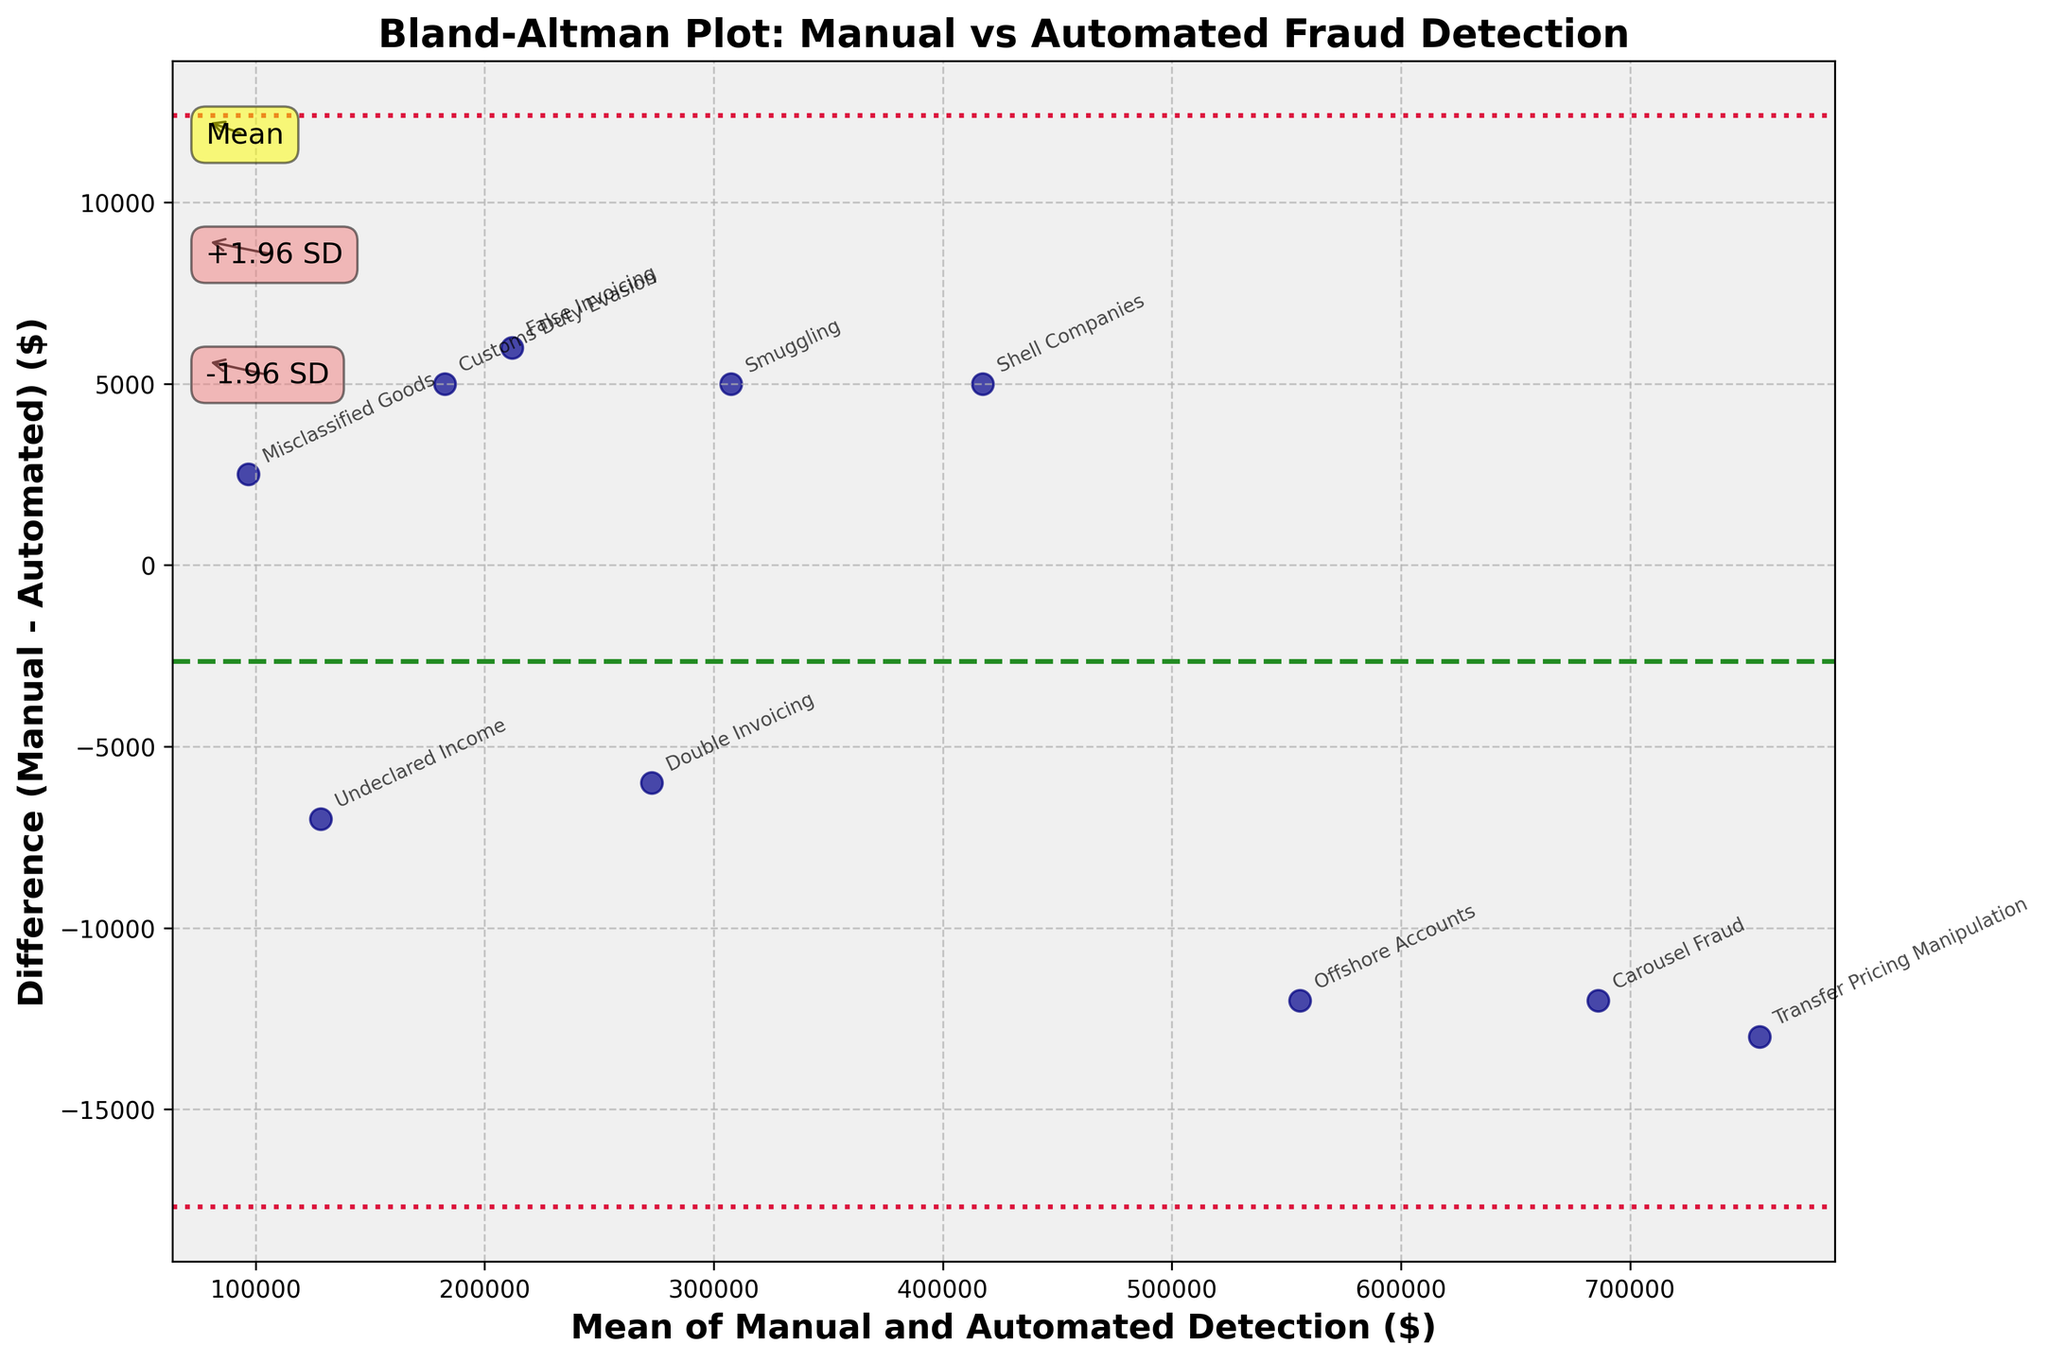What is the title of the plot? The title of the plot is written at the top of the figure in bold font, which provides an overview of what the plot represents.
Answer: Bland-Altman Plot: Manual vs Automated Fraud Detection How many types of fraud detection methods are compared in the plot? Count the number of distinct labels (methods) annotated in the scatter plot. There are 10 different labels in the figure.
Answer: 10 What do the green and red lines represent in the plot? The green dashed line represents the mean difference between the manual and automated detection methods. The red dotted lines represent the limits of agreement (mean ± 1.96 standard deviations).
Answer: Mean difference, Limits of agreement Which fraud detection method shows the largest difference between manual and automated detection? Identify the point with the highest (or lowest) position on the y-axis, which corresponds to the difference (manual - automated). "Transfer Pricing Manipulation" shows the largest positive difference.
Answer: Transfer Pricing Manipulation What is the mean difference between the manual and automated detection methods? The mean difference is marked by the green dashed line and labeled "Mean" on the y-axis.
Answer: Approximately 4,700 Are there any points that fall outside the limits of agreement? Check if any points fall above the upper red dotted line (+1.96 SD) or below the lower red dotted line (-1.96 SD).
Answer: No What is the mean detection value for Misclassified Goods across both methods? Find the mean of the manual and automated values for Misclassified Goods and calculate their average. (98,000 + 95,500)/2 = 96,750
Answer: 96,750 Which detection method tends to report higher values for fraud detection? Compare the overall trend of the differences. Most points lie below the mean line, indicating manual detection tends to report higher values.
Answer: Manual Detection How variable are the differences between manual and automated detection across fraud types? Look at the spread of the points along the y-axis to evaluate the variability of the differences. The range seems broad, indicating high variability.
Answer: High Is there evidence of systematic bias between the manual and automated methods? Since the mean difference line is close to zero and differences are widely spread without a clear trend around zero, it suggests some systematic bias but not strongly.
Answer: Some bias 